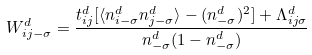<formula> <loc_0><loc_0><loc_500><loc_500>W _ { i j - \sigma } ^ { d } = \frac { t _ { i j } ^ { d } [ \langle n _ { i - \sigma } ^ { d } n _ { j - \sigma } ^ { d } \rangle - ( n _ { - \sigma } ^ { d } ) ^ { 2 } ] + \Lambda _ { i j \sigma } ^ { d } } { n _ { - \sigma } ^ { d } ( 1 - n _ { - \sigma } ^ { d } ) }</formula> 